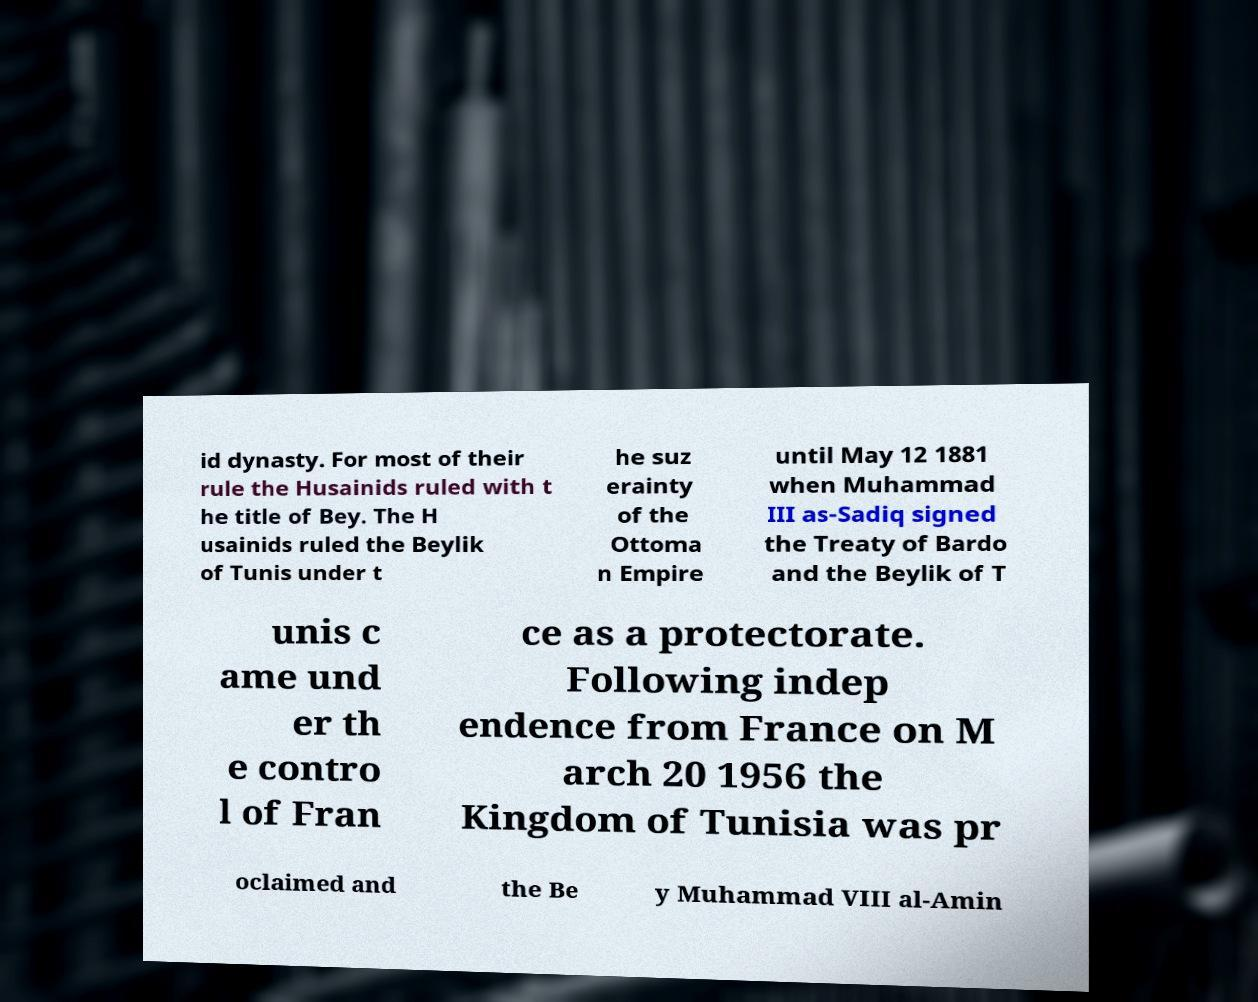Please identify and transcribe the text found in this image. id dynasty. For most of their rule the Husainids ruled with t he title of Bey. The H usainids ruled the Beylik of Tunis under t he suz erainty of the Ottoma n Empire until May 12 1881 when Muhammad III as-Sadiq signed the Treaty of Bardo and the Beylik of T unis c ame und er th e contro l of Fran ce as a protectorate. Following indep endence from France on M arch 20 1956 the Kingdom of Tunisia was pr oclaimed and the Be y Muhammad VIII al-Amin 